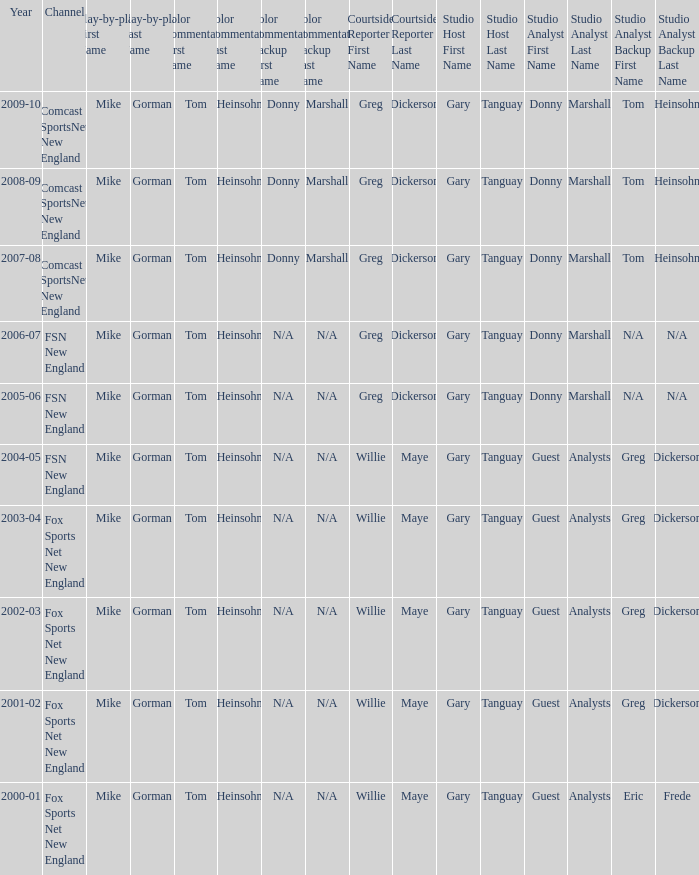WHich Studio analysts has a Studio host of gary tanguay in 2009-10? Donny Marshall or Tom Heinsohn (Select road games). 